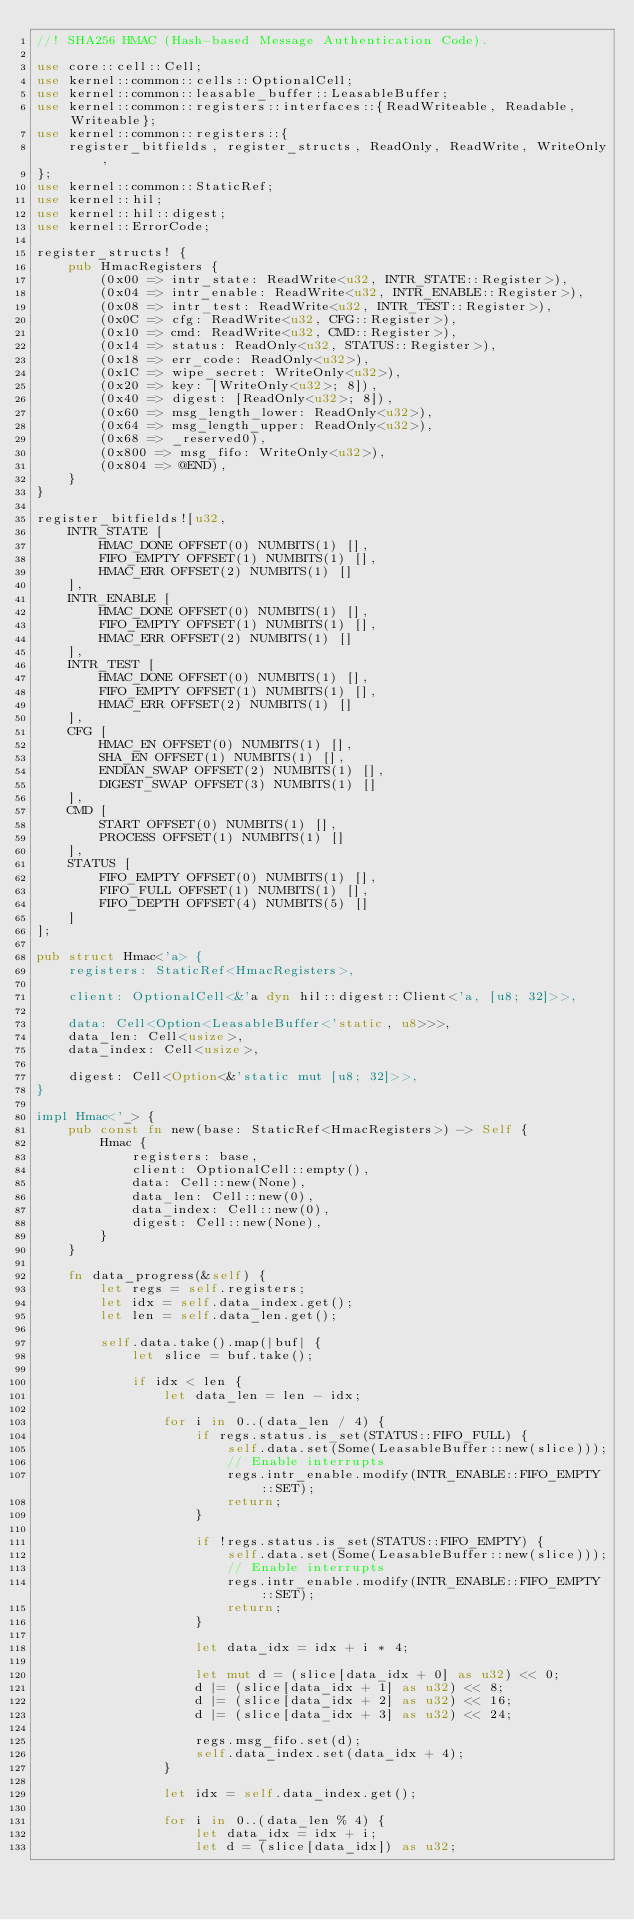Convert code to text. <code><loc_0><loc_0><loc_500><loc_500><_Rust_>//! SHA256 HMAC (Hash-based Message Authentication Code).

use core::cell::Cell;
use kernel::common::cells::OptionalCell;
use kernel::common::leasable_buffer::LeasableBuffer;
use kernel::common::registers::interfaces::{ReadWriteable, Readable, Writeable};
use kernel::common::registers::{
    register_bitfields, register_structs, ReadOnly, ReadWrite, WriteOnly,
};
use kernel::common::StaticRef;
use kernel::hil;
use kernel::hil::digest;
use kernel::ErrorCode;

register_structs! {
    pub HmacRegisters {
        (0x00 => intr_state: ReadWrite<u32, INTR_STATE::Register>),
        (0x04 => intr_enable: ReadWrite<u32, INTR_ENABLE::Register>),
        (0x08 => intr_test: ReadWrite<u32, INTR_TEST::Register>),
        (0x0C => cfg: ReadWrite<u32, CFG::Register>),
        (0x10 => cmd: ReadWrite<u32, CMD::Register>),
        (0x14 => status: ReadOnly<u32, STATUS::Register>),
        (0x18 => err_code: ReadOnly<u32>),
        (0x1C => wipe_secret: WriteOnly<u32>),
        (0x20 => key: [WriteOnly<u32>; 8]),
        (0x40 => digest: [ReadOnly<u32>; 8]),
        (0x60 => msg_length_lower: ReadOnly<u32>),
        (0x64 => msg_length_upper: ReadOnly<u32>),
        (0x68 => _reserved0),
        (0x800 => msg_fifo: WriteOnly<u32>),
        (0x804 => @END),
    }
}

register_bitfields![u32,
    INTR_STATE [
        HMAC_DONE OFFSET(0) NUMBITS(1) [],
        FIFO_EMPTY OFFSET(1) NUMBITS(1) [],
        HMAC_ERR OFFSET(2) NUMBITS(1) []
    ],
    INTR_ENABLE [
        HMAC_DONE OFFSET(0) NUMBITS(1) [],
        FIFO_EMPTY OFFSET(1) NUMBITS(1) [],
        HMAC_ERR OFFSET(2) NUMBITS(1) []
    ],
    INTR_TEST [
        HMAC_DONE OFFSET(0) NUMBITS(1) [],
        FIFO_EMPTY OFFSET(1) NUMBITS(1) [],
        HMAC_ERR OFFSET(2) NUMBITS(1) []
    ],
    CFG [
        HMAC_EN OFFSET(0) NUMBITS(1) [],
        SHA_EN OFFSET(1) NUMBITS(1) [],
        ENDIAN_SWAP OFFSET(2) NUMBITS(1) [],
        DIGEST_SWAP OFFSET(3) NUMBITS(1) []
    ],
    CMD [
        START OFFSET(0) NUMBITS(1) [],
        PROCESS OFFSET(1) NUMBITS(1) []
    ],
    STATUS [
        FIFO_EMPTY OFFSET(0) NUMBITS(1) [],
        FIFO_FULL OFFSET(1) NUMBITS(1) [],
        FIFO_DEPTH OFFSET(4) NUMBITS(5) []
    ]
];

pub struct Hmac<'a> {
    registers: StaticRef<HmacRegisters>,

    client: OptionalCell<&'a dyn hil::digest::Client<'a, [u8; 32]>>,

    data: Cell<Option<LeasableBuffer<'static, u8>>>,
    data_len: Cell<usize>,
    data_index: Cell<usize>,

    digest: Cell<Option<&'static mut [u8; 32]>>,
}

impl Hmac<'_> {
    pub const fn new(base: StaticRef<HmacRegisters>) -> Self {
        Hmac {
            registers: base,
            client: OptionalCell::empty(),
            data: Cell::new(None),
            data_len: Cell::new(0),
            data_index: Cell::new(0),
            digest: Cell::new(None),
        }
    }

    fn data_progress(&self) {
        let regs = self.registers;
        let idx = self.data_index.get();
        let len = self.data_len.get();

        self.data.take().map(|buf| {
            let slice = buf.take();

            if idx < len {
                let data_len = len - idx;

                for i in 0..(data_len / 4) {
                    if regs.status.is_set(STATUS::FIFO_FULL) {
                        self.data.set(Some(LeasableBuffer::new(slice)));
                        // Enable interrupts
                        regs.intr_enable.modify(INTR_ENABLE::FIFO_EMPTY::SET);
                        return;
                    }

                    if !regs.status.is_set(STATUS::FIFO_EMPTY) {
                        self.data.set(Some(LeasableBuffer::new(slice)));
                        // Enable interrupts
                        regs.intr_enable.modify(INTR_ENABLE::FIFO_EMPTY::SET);
                        return;
                    }

                    let data_idx = idx + i * 4;

                    let mut d = (slice[data_idx + 0] as u32) << 0;
                    d |= (slice[data_idx + 1] as u32) << 8;
                    d |= (slice[data_idx + 2] as u32) << 16;
                    d |= (slice[data_idx + 3] as u32) << 24;

                    regs.msg_fifo.set(d);
                    self.data_index.set(data_idx + 4);
                }

                let idx = self.data_index.get();

                for i in 0..(data_len % 4) {
                    let data_idx = idx + i;
                    let d = (slice[data_idx]) as u32;
</code> 